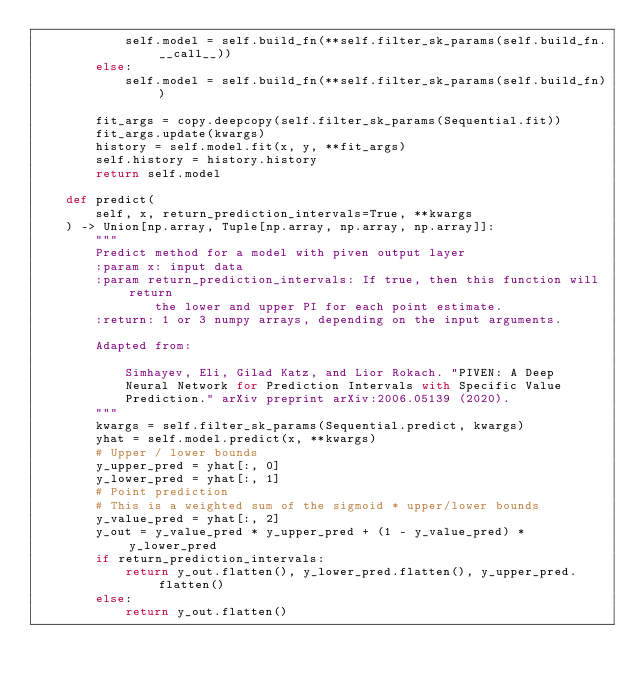<code> <loc_0><loc_0><loc_500><loc_500><_Python_>            self.model = self.build_fn(**self.filter_sk_params(self.build_fn.__call__))
        else:
            self.model = self.build_fn(**self.filter_sk_params(self.build_fn))

        fit_args = copy.deepcopy(self.filter_sk_params(Sequential.fit))
        fit_args.update(kwargs)
        history = self.model.fit(x, y, **fit_args)
        self.history = history.history
        return self.model

    def predict(
        self, x, return_prediction_intervals=True, **kwargs
    ) -> Union[np.array, Tuple[np.array, np.array, np.array]]:
        """
        Predict method for a model with piven output layer
        :param x: input data
        :param return_prediction_intervals: If true, then this function will return
                the lower and upper PI for each point estimate.
        :return: 1 or 3 numpy arrays, depending on the input arguments.

        Adapted from:

            Simhayev, Eli, Gilad Katz, and Lior Rokach. "PIVEN: A Deep
            Neural Network for Prediction Intervals with Specific Value
            Prediction." arXiv preprint arXiv:2006.05139 (2020).
        """
        kwargs = self.filter_sk_params(Sequential.predict, kwargs)
        yhat = self.model.predict(x, **kwargs)
        # Upper / lower bounds
        y_upper_pred = yhat[:, 0]
        y_lower_pred = yhat[:, 1]
        # Point prediction
        # This is a weighted sum of the sigmoid * upper/lower bounds
        y_value_pred = yhat[:, 2]
        y_out = y_value_pred * y_upper_pred + (1 - y_value_pred) * y_lower_pred
        if return_prediction_intervals:
            return y_out.flatten(), y_lower_pred.flatten(), y_upper_pred.flatten()
        else:
            return y_out.flatten()
</code> 